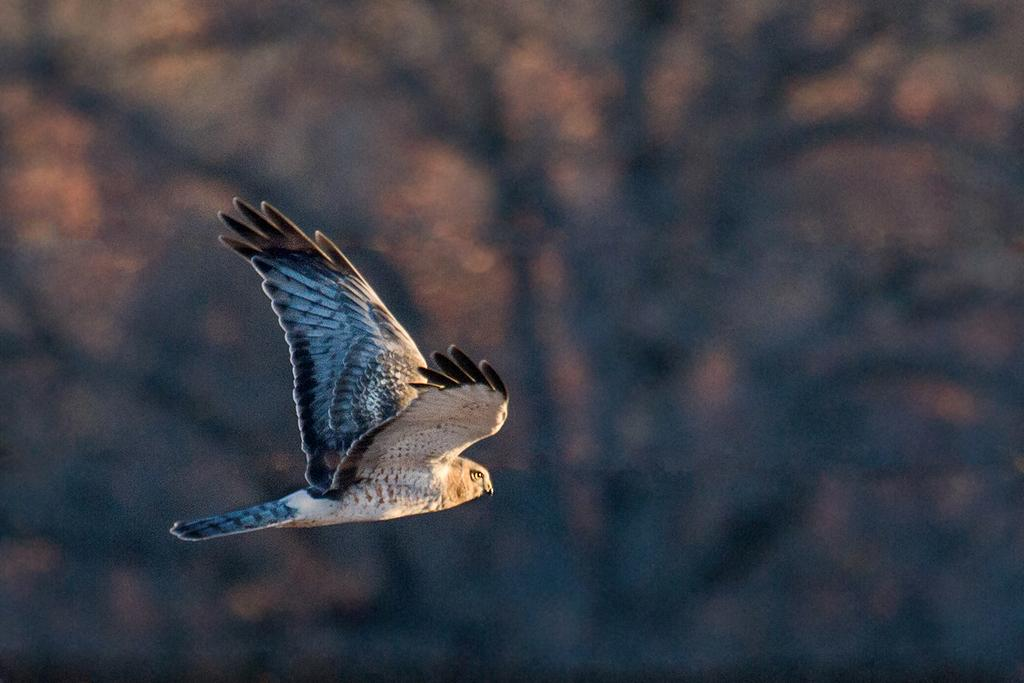What type of animal can be seen in the image? There is a bird in the image. Can you describe the background of the image? The background of the image is blurred. What type of coat is the bird wearing in the image? There is no coat present on the bird in the image, as birds do not wear clothing. 